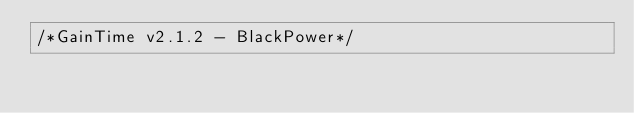<code> <loc_0><loc_0><loc_500><loc_500><_CSS_>/*GainTime v2.1.2 - BlackPower*/</code> 